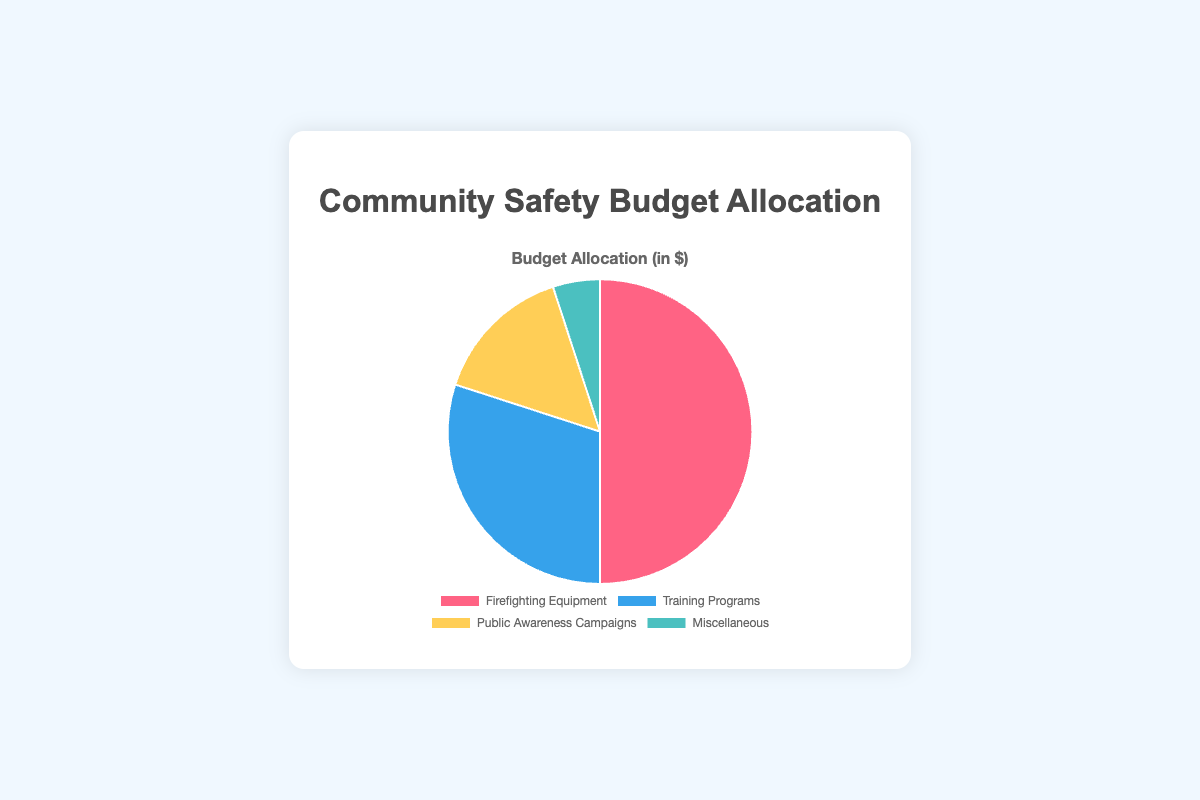Which initiative receives the largest portion of the budget? The largest portion of the budget goes to the section with the largest slice in the pie chart. The label for this slice is "Firefighting Equipment," which has the highest budget allocation.
Answer: Firefighting Equipment How much more is allocated to Firefighting Equipment compared to Miscellaneous? To find how much more is allocated to Firefighting Equipment compared to Miscellaneous, subtract the Miscellaneous allocation from the Firefighting Equipment allocation (500,000 - 50,000).
Answer: 450,000 What percentage of the total budget is allocated to Training Programs? First, calculate the total budget by summing all the allocations (500,000 + 300,000 + 150,000 + 50,000 = 1,000,000). Then, find the percentage allocated to Training Programs by dividing the Training Programs budget by the total budget and multiplying by 100 (300,000 / 1,000,000 * 100).
Answer: 30% Which color represents the Public Awareness Campaigns section on the pie chart? Look at the color of the slice in the pie chart that corresponds to the "Public Awareness Campaigns" label. This slice is represented by the color yellow.
Answer: Yellow If the total budget were doubled, how much would be allocated to Miscellaneous? If the total budget were doubled, each category's budget would also double. The current allocation for Miscellaneous is 50,000. So, double that amount (50,000 * 2).
Answer: 100,000 Is the budget for Training Programs more than the combined budget for Public Awareness Campaigns and Miscellaneous? First, find the combined budget for Public Awareness Campaigns and Miscellaneous (150,000 + 50,000 = 200,000). Then compare it with the budget for Training Programs (300,000 > 200,000).
Answer: Yes What fraction of the budget is allocated to Firefighting Equipment? Calculate the total budget by summing all allocations (1,000,000). The fraction for Firefighting Equipment is its budget divided by the total budget (500,000 / 1,000,000).
Answer: 1/2 How does the allocation for Public Awareness Campaigns compare to Training Programs? Compare the budget for Public Awareness Campaigns (150,000) to Training Programs (300,000). Public Awareness Campaigns have half the budget of Training Programs (150,000 is half of 300,000).
Answer: Half What is the difference in budget between the smallest and largest allocations? Identify the smallest allocation (Miscellaneous: 50,000) and the largest allocation (Firefighting Equipment: 500,000), then subtract the smallest from the largest (500,000 - 50,000).
Answer: 450,000 